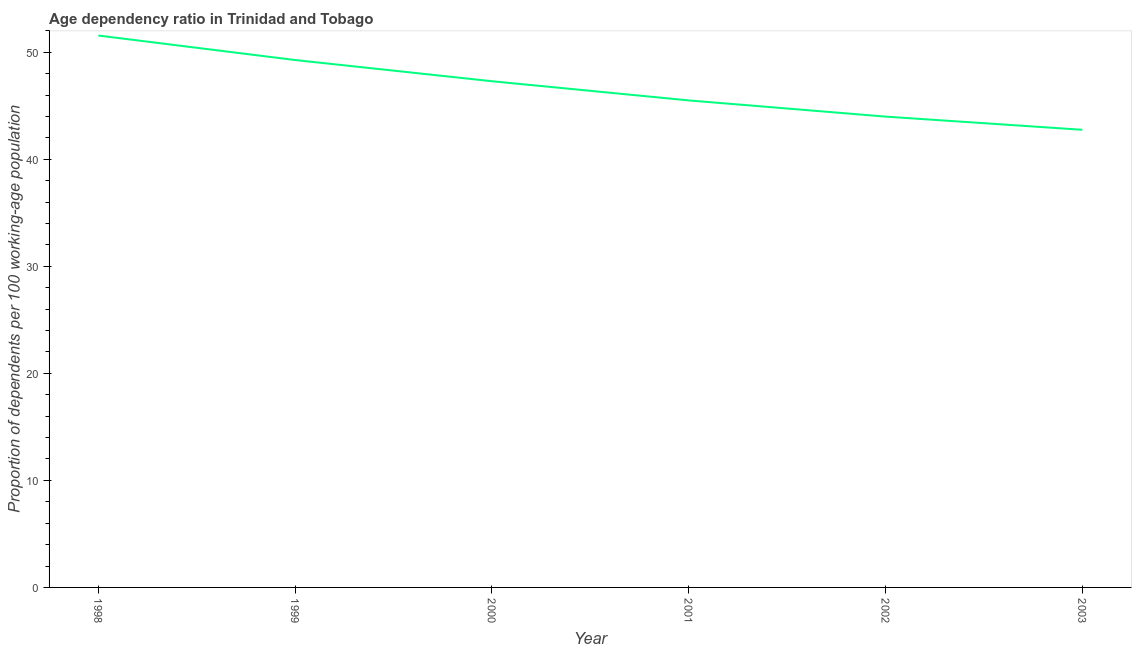What is the age dependency ratio in 1999?
Your answer should be compact. 49.28. Across all years, what is the maximum age dependency ratio?
Give a very brief answer. 51.57. Across all years, what is the minimum age dependency ratio?
Offer a very short reply. 42.76. What is the sum of the age dependency ratio?
Provide a short and direct response. 280.39. What is the difference between the age dependency ratio in 1999 and 2003?
Your answer should be compact. 6.52. What is the average age dependency ratio per year?
Your answer should be compact. 46.73. What is the median age dependency ratio?
Make the answer very short. 46.4. What is the ratio of the age dependency ratio in 2000 to that in 2001?
Your answer should be compact. 1.04. Is the age dependency ratio in 1998 less than that in 2002?
Keep it short and to the point. No. What is the difference between the highest and the second highest age dependency ratio?
Your answer should be very brief. 2.29. Is the sum of the age dependency ratio in 1998 and 2001 greater than the maximum age dependency ratio across all years?
Your response must be concise. Yes. What is the difference between the highest and the lowest age dependency ratio?
Your answer should be compact. 8.81. In how many years, is the age dependency ratio greater than the average age dependency ratio taken over all years?
Give a very brief answer. 3. Does the age dependency ratio monotonically increase over the years?
Give a very brief answer. No. How many lines are there?
Make the answer very short. 1. Are the values on the major ticks of Y-axis written in scientific E-notation?
Provide a short and direct response. No. Does the graph contain any zero values?
Keep it short and to the point. No. Does the graph contain grids?
Your response must be concise. No. What is the title of the graph?
Make the answer very short. Age dependency ratio in Trinidad and Tobago. What is the label or title of the X-axis?
Make the answer very short. Year. What is the label or title of the Y-axis?
Your response must be concise. Proportion of dependents per 100 working-age population. What is the Proportion of dependents per 100 working-age population of 1998?
Make the answer very short. 51.57. What is the Proportion of dependents per 100 working-age population of 1999?
Make the answer very short. 49.28. What is the Proportion of dependents per 100 working-age population in 2000?
Ensure brevity in your answer.  47.3. What is the Proportion of dependents per 100 working-age population of 2001?
Your answer should be very brief. 45.5. What is the Proportion of dependents per 100 working-age population of 2002?
Give a very brief answer. 43.99. What is the Proportion of dependents per 100 working-age population of 2003?
Provide a short and direct response. 42.76. What is the difference between the Proportion of dependents per 100 working-age population in 1998 and 1999?
Your answer should be very brief. 2.29. What is the difference between the Proportion of dependents per 100 working-age population in 1998 and 2000?
Offer a terse response. 4.27. What is the difference between the Proportion of dependents per 100 working-age population in 1998 and 2001?
Provide a short and direct response. 6.06. What is the difference between the Proportion of dependents per 100 working-age population in 1998 and 2002?
Offer a very short reply. 7.57. What is the difference between the Proportion of dependents per 100 working-age population in 1998 and 2003?
Provide a succinct answer. 8.81. What is the difference between the Proportion of dependents per 100 working-age population in 1999 and 2000?
Provide a short and direct response. 1.98. What is the difference between the Proportion of dependents per 100 working-age population in 1999 and 2001?
Provide a succinct answer. 3.77. What is the difference between the Proportion of dependents per 100 working-age population in 1999 and 2002?
Give a very brief answer. 5.29. What is the difference between the Proportion of dependents per 100 working-age population in 1999 and 2003?
Give a very brief answer. 6.52. What is the difference between the Proportion of dependents per 100 working-age population in 2000 and 2001?
Your answer should be compact. 1.79. What is the difference between the Proportion of dependents per 100 working-age population in 2000 and 2002?
Keep it short and to the point. 3.3. What is the difference between the Proportion of dependents per 100 working-age population in 2000 and 2003?
Your response must be concise. 4.54. What is the difference between the Proportion of dependents per 100 working-age population in 2001 and 2002?
Ensure brevity in your answer.  1.51. What is the difference between the Proportion of dependents per 100 working-age population in 2001 and 2003?
Provide a short and direct response. 2.75. What is the difference between the Proportion of dependents per 100 working-age population in 2002 and 2003?
Provide a short and direct response. 1.23. What is the ratio of the Proportion of dependents per 100 working-age population in 1998 to that in 1999?
Your answer should be compact. 1.05. What is the ratio of the Proportion of dependents per 100 working-age population in 1998 to that in 2000?
Provide a succinct answer. 1.09. What is the ratio of the Proportion of dependents per 100 working-age population in 1998 to that in 2001?
Ensure brevity in your answer.  1.13. What is the ratio of the Proportion of dependents per 100 working-age population in 1998 to that in 2002?
Your response must be concise. 1.17. What is the ratio of the Proportion of dependents per 100 working-age population in 1998 to that in 2003?
Ensure brevity in your answer.  1.21. What is the ratio of the Proportion of dependents per 100 working-age population in 1999 to that in 2000?
Make the answer very short. 1.04. What is the ratio of the Proportion of dependents per 100 working-age population in 1999 to that in 2001?
Your answer should be compact. 1.08. What is the ratio of the Proportion of dependents per 100 working-age population in 1999 to that in 2002?
Give a very brief answer. 1.12. What is the ratio of the Proportion of dependents per 100 working-age population in 1999 to that in 2003?
Make the answer very short. 1.15. What is the ratio of the Proportion of dependents per 100 working-age population in 2000 to that in 2001?
Your answer should be compact. 1.04. What is the ratio of the Proportion of dependents per 100 working-age population in 2000 to that in 2002?
Make the answer very short. 1.07. What is the ratio of the Proportion of dependents per 100 working-age population in 2000 to that in 2003?
Give a very brief answer. 1.11. What is the ratio of the Proportion of dependents per 100 working-age population in 2001 to that in 2002?
Provide a short and direct response. 1.03. What is the ratio of the Proportion of dependents per 100 working-age population in 2001 to that in 2003?
Provide a succinct answer. 1.06. What is the ratio of the Proportion of dependents per 100 working-age population in 2002 to that in 2003?
Keep it short and to the point. 1.03. 